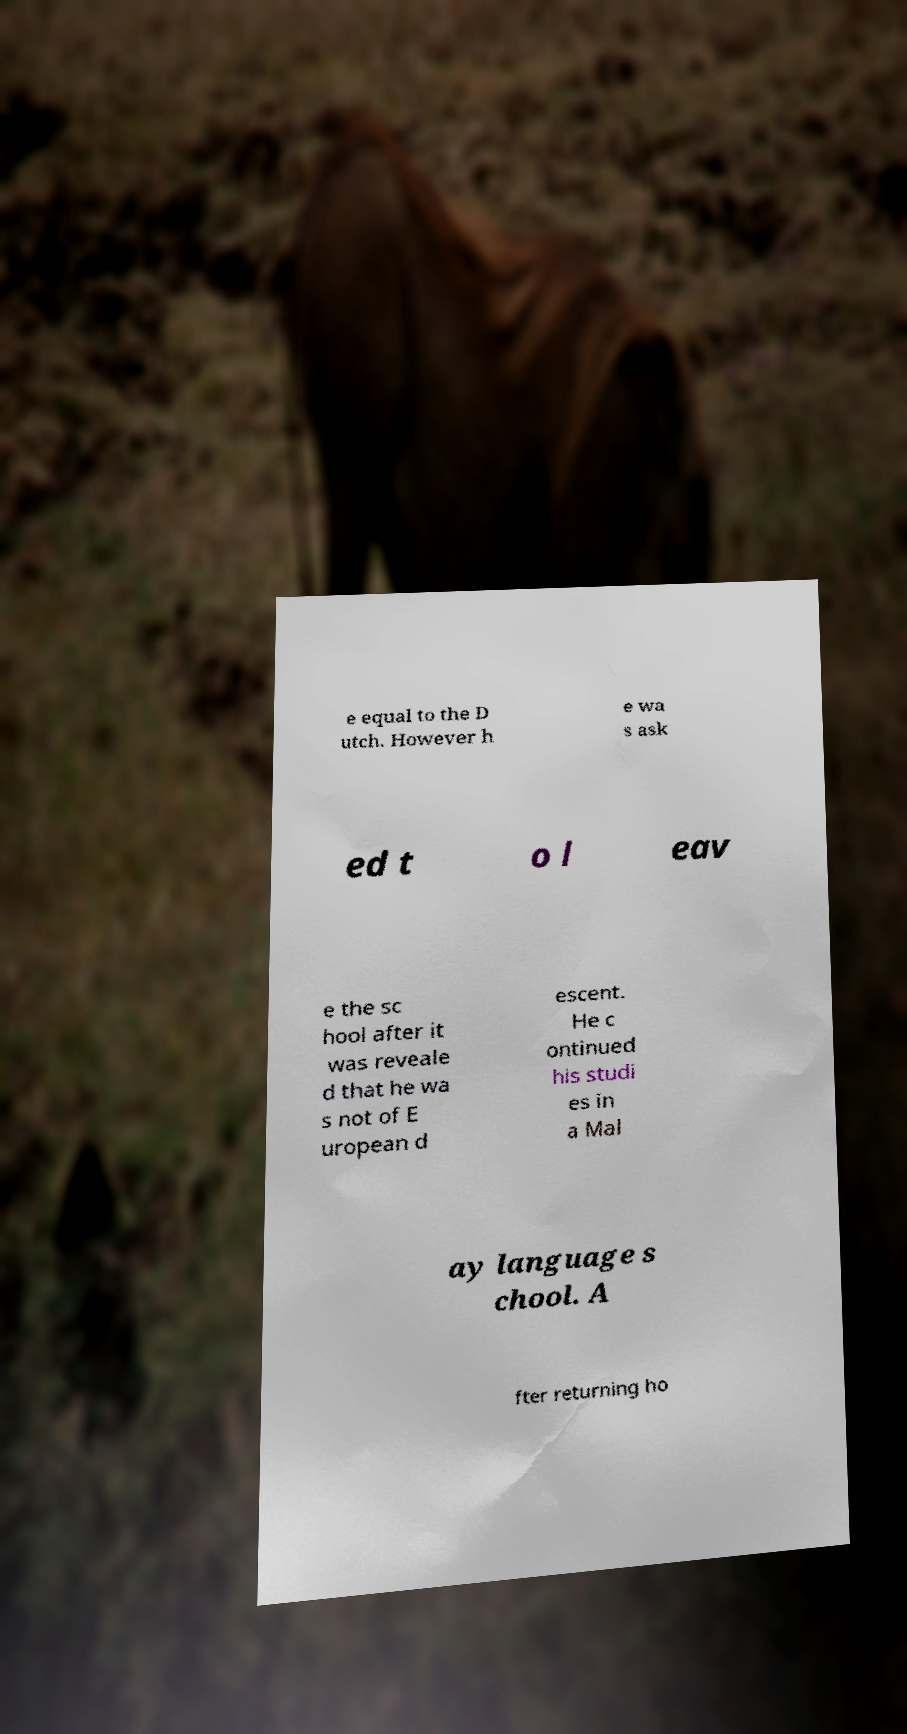Please read and relay the text visible in this image. What does it say? e equal to the D utch. However h e wa s ask ed t o l eav e the sc hool after it was reveale d that he wa s not of E uropean d escent. He c ontinued his studi es in a Mal ay language s chool. A fter returning ho 